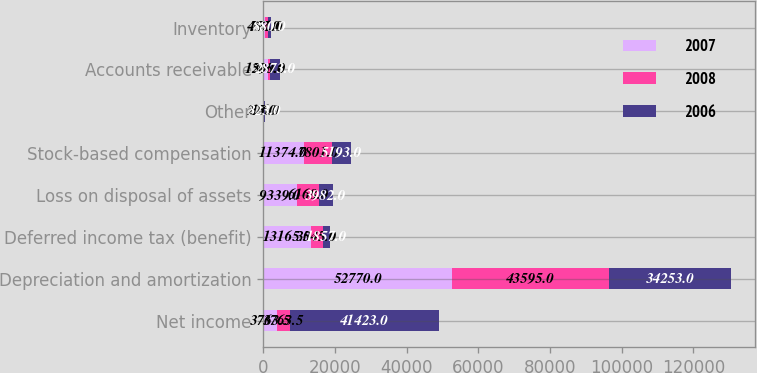Convert chart. <chart><loc_0><loc_0><loc_500><loc_500><stacked_bar_chart><ecel><fcel>Net income<fcel>Depreciation and amortization<fcel>Deferred income tax (benefit)<fcel>Loss on disposal of assets<fcel>Stock-based compensation<fcel>Other<fcel>Accounts receivable<fcel>Inventory<nl><fcel>2007<fcel>3763.5<fcel>52770<fcel>13165<fcel>9339<fcel>11374<fcel>226<fcel>1290<fcel>457<nl><fcel>2008<fcel>3763.5<fcel>43595<fcel>3545<fcel>6168<fcel>7801<fcel>15<fcel>508<fcel>771<nl><fcel>2006<fcel>41423<fcel>34253<fcel>1857<fcel>3982<fcel>5193<fcel>323<fcel>2873<fcel>880<nl></chart> 